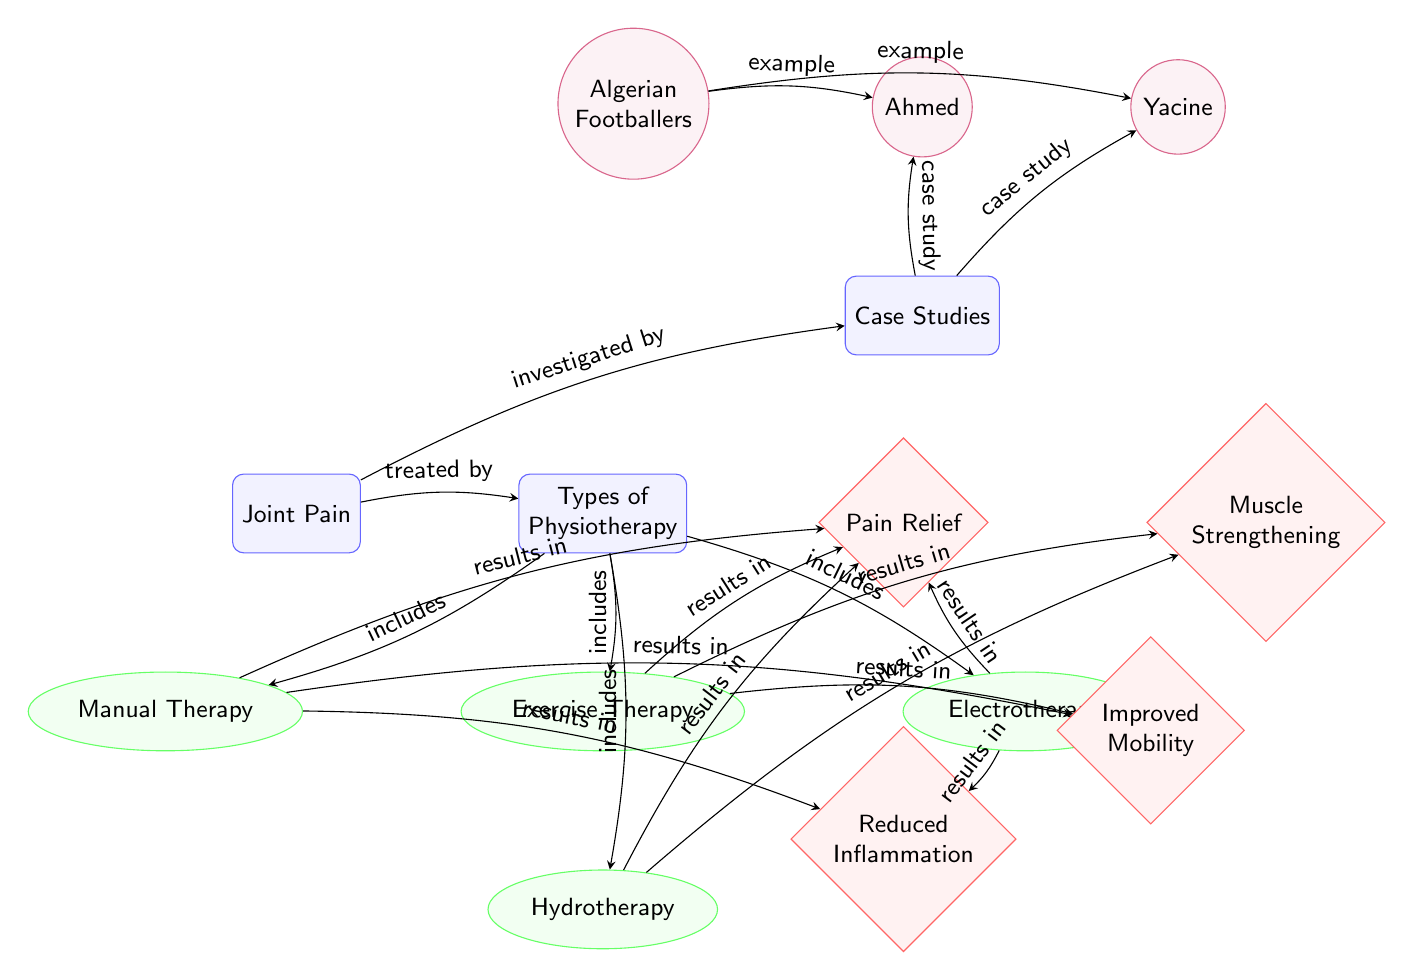What is treated by physiotherapy? The diagram shows that "Joint Pain" is treated by "Physiotherapy," which is represented as a connection from the "Joint Pain" node to the "Types of Physiotherapy" node.
Answer: Joint Pain How many types of physiotherapy are included? The diagram lists four types of physiotherapy: Exercise Therapy, Manual Therapy, Electrotherapy, and Hydrotherapy. Counting these types gives us a total of four.
Answer: 4 What results from exercise therapy? According to the diagram, "Exercise Therapy" results in multiple benefits: "Pain Relief," "Muscle Strengthening," and "Improved Mobility." The first node connected to exercise therapy provides these outcomes.
Answer: Pain Relief, Muscle Strengthening, Improved Mobility Which physiotherapy method reduces inflammation? The connections show that "Manual Therapy" and "Electrotherapy" both lead to the outcome of "Reduced Inflammation," indicating they are effective methods for this result.
Answer: Manual Therapy, Electrotherapy Who are examples of individuals investigated in the case studies? The diagram highlights two individuals connected to the "Case Studies" node: "Ahmed" and "Yacine," serving as examples of athletes studied concerning joint pain.
Answer: Ahmed, Yacine What is the main outcome of manual therapy? The diagram indicates that "Manual Therapy" results in three primary outcomes, one being "Pain Relief," which is the first direct connection illustrated.
Answer: Pain Relief Which type of physiotherapy provides muscle strengthening as a result? The diagram specifies that "Exercise Therapy" is the type of physiotherapy from which "Muscle Strengthening" directly results, as shown by the arrows connecting the respective nodes.
Answer: Exercise Therapy How many outcomes are connected to hydrotherapy? Hydrotherapy shows connections to two outcomes: "Pain Relief" and "Muscle Strengthening," indicating that there are two results linked to this type of therapy.
Answer: 2 